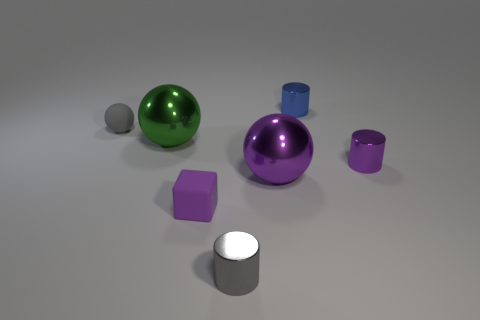Subtract all blue cylinders. How many cylinders are left? 2 Add 2 big green balls. How many objects exist? 9 Subtract 1 cylinders. How many cylinders are left? 2 Subtract all cylinders. How many objects are left? 4 Subtract all purple spheres. How many spheres are left? 2 Add 4 purple shiny spheres. How many purple shiny spheres are left? 5 Add 7 small blue cylinders. How many small blue cylinders exist? 8 Subtract 0 yellow balls. How many objects are left? 7 Subtract all cyan cubes. Subtract all cyan cylinders. How many cubes are left? 1 Subtract all big things. Subtract all tiny gray objects. How many objects are left? 3 